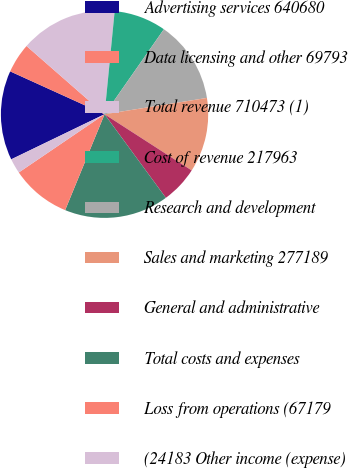Convert chart to OTSL. <chart><loc_0><loc_0><loc_500><loc_500><pie_chart><fcel>Advertising services 640680<fcel>Data licensing and other 69793<fcel>Total revenue 710473 (1)<fcel>Cost of revenue 217963<fcel>Research and development<fcel>Sales and marketing 277189<fcel>General and administrative<fcel>Total costs and expenses<fcel>Loss from operations (67179<fcel>(24183 Other income (expense)<nl><fcel>13.95%<fcel>4.65%<fcel>15.12%<fcel>8.14%<fcel>12.79%<fcel>11.63%<fcel>5.81%<fcel>16.28%<fcel>9.3%<fcel>2.33%<nl></chart> 